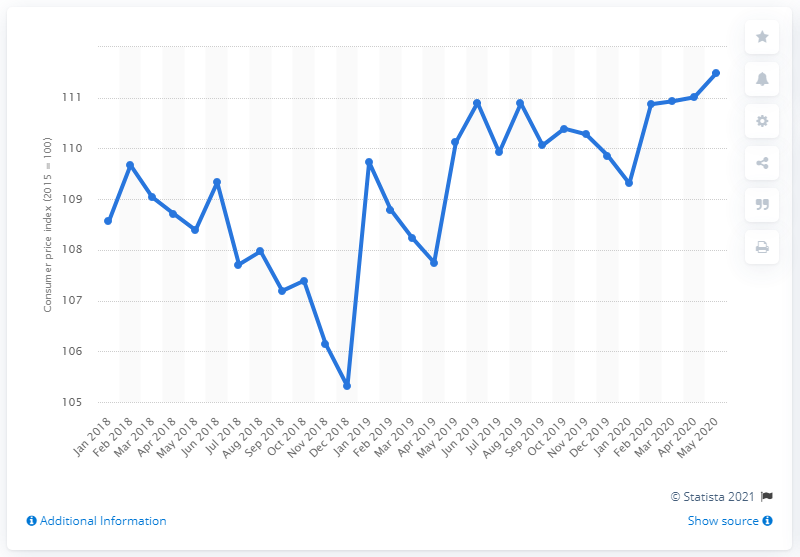Identify some key points in this picture. The Consumer Price Index's (CPI) index value in May 2020 was 111.48. In January 2018, the index value for fruit juice was 108.56, and the index value for vegetable juice was also 108.56. 